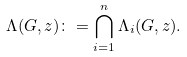<formula> <loc_0><loc_0><loc_500><loc_500>\Lambda ( G , z ) \colon = \bigcap _ { i = 1 } ^ { n } \Lambda _ { i } ( G , z ) .</formula> 